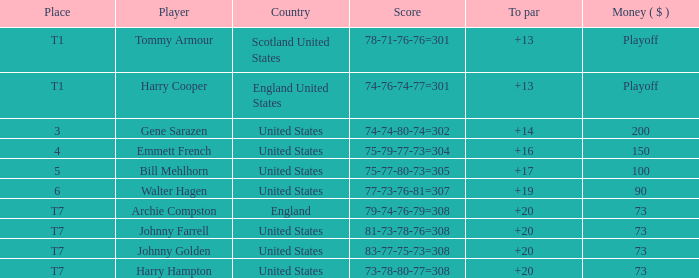Which country has a to par less than 19 and a score of 75-79-77-73=304? United States. 